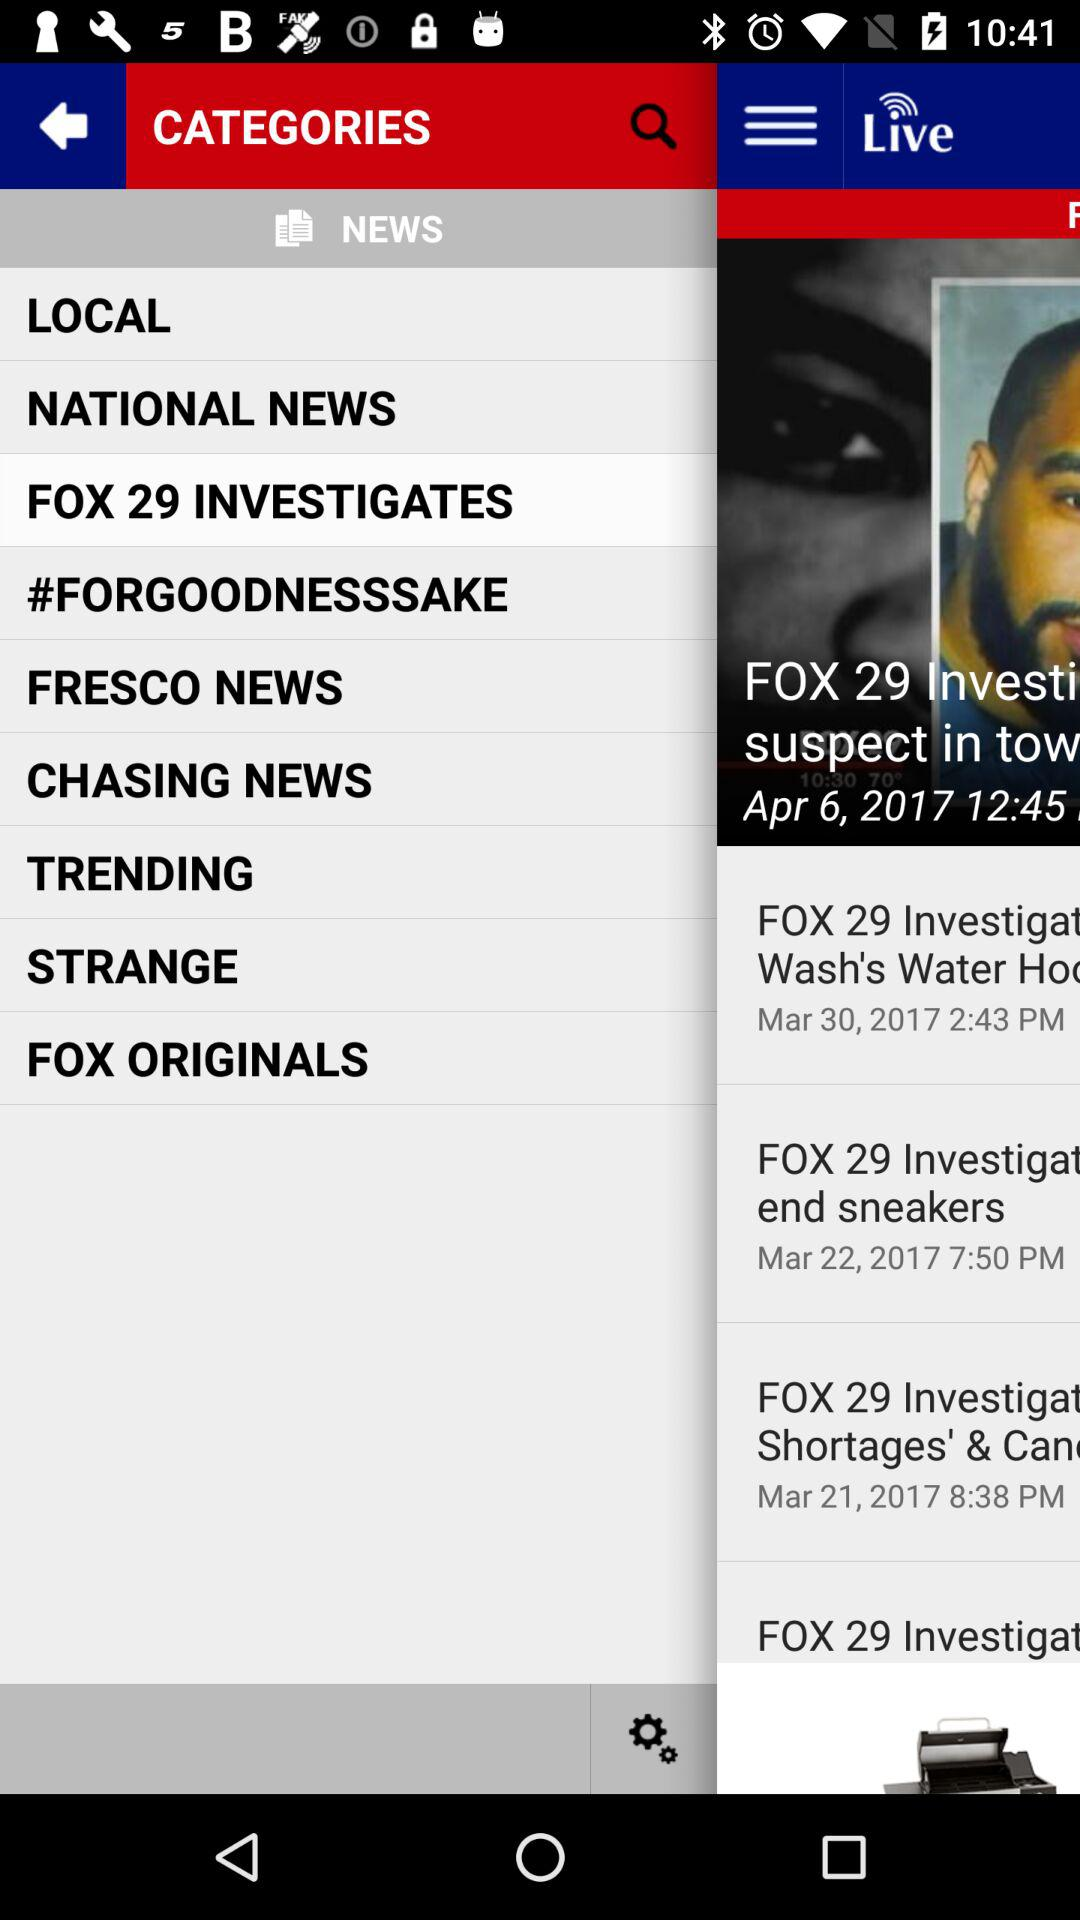How many items have a date and time?
Answer the question using a single word or phrase. 4 